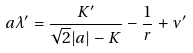<formula> <loc_0><loc_0><loc_500><loc_500>a \lambda ^ { \prime } = \frac { K ^ { \prime } } { \sqrt { 2 } | a | - K } - \frac { 1 } { r } + \nu ^ { \prime }</formula> 